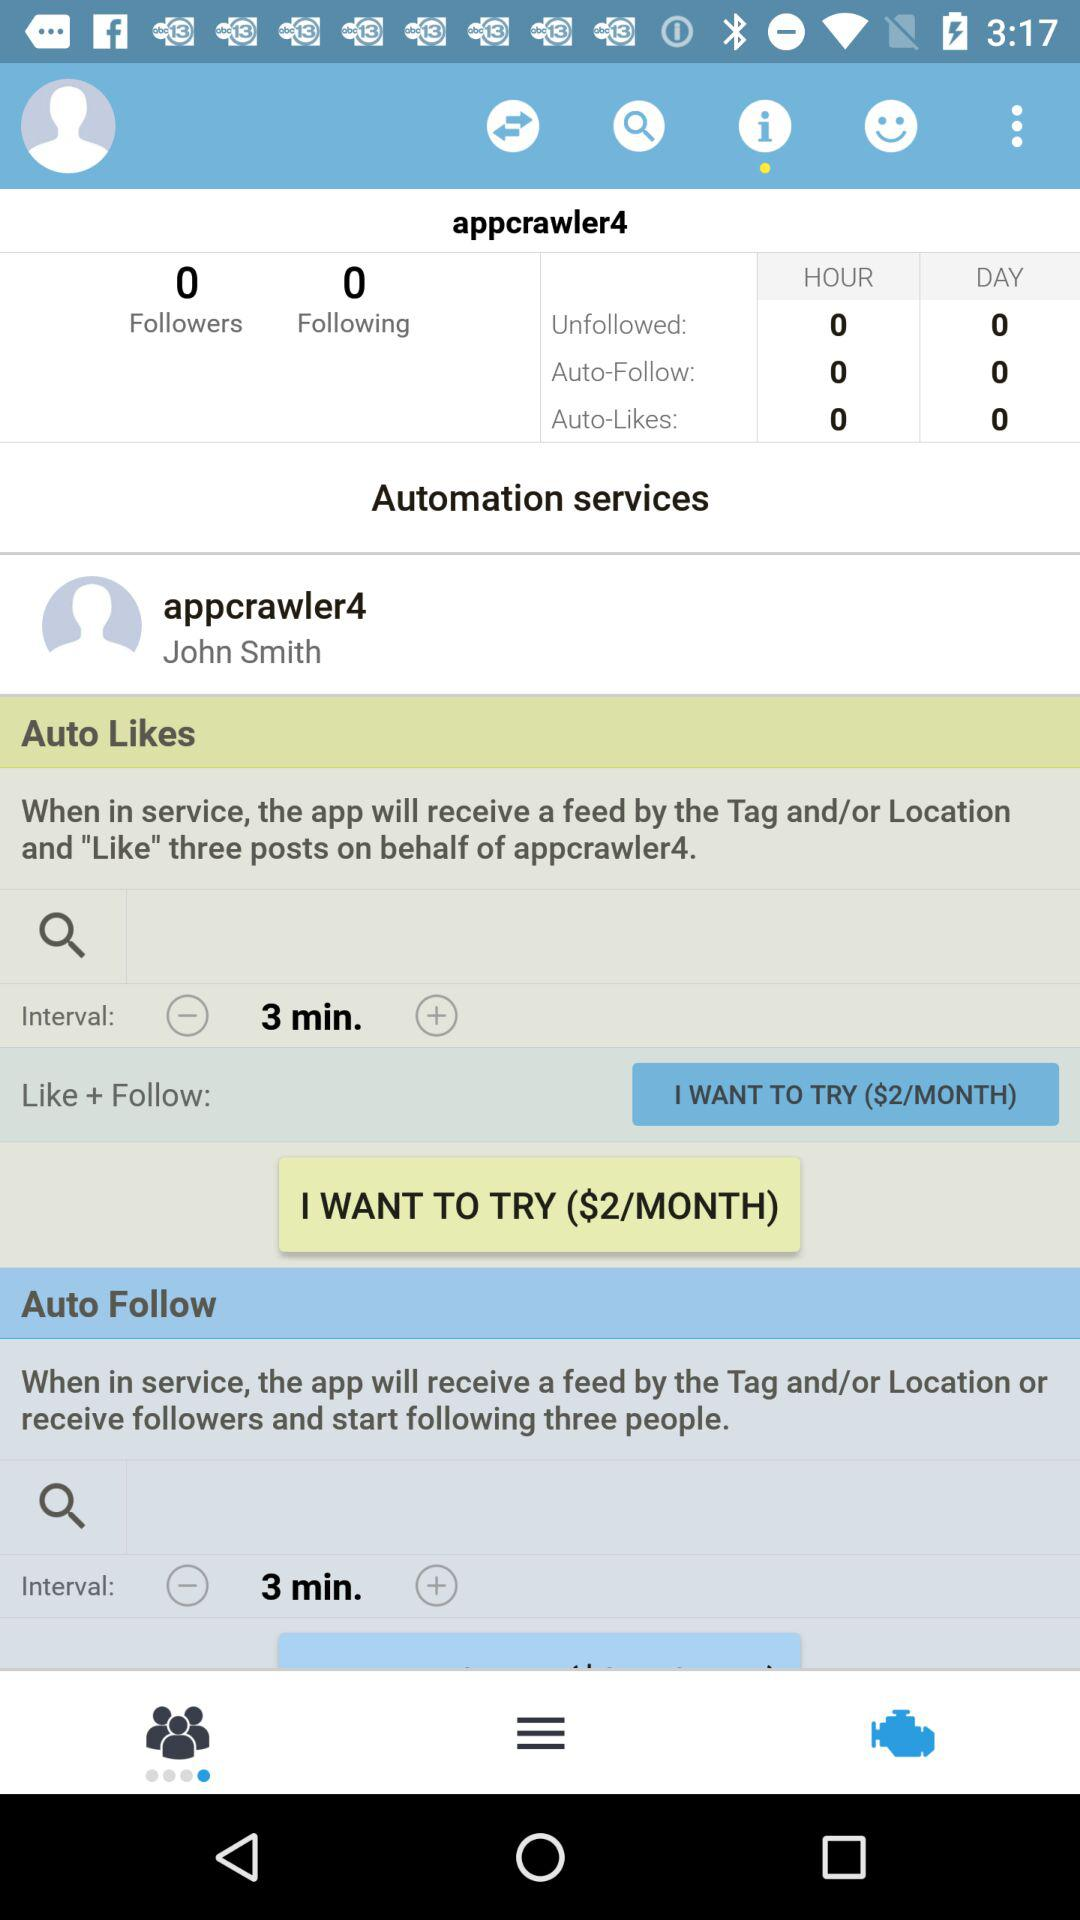How many followers are there? There are 0 followers. 